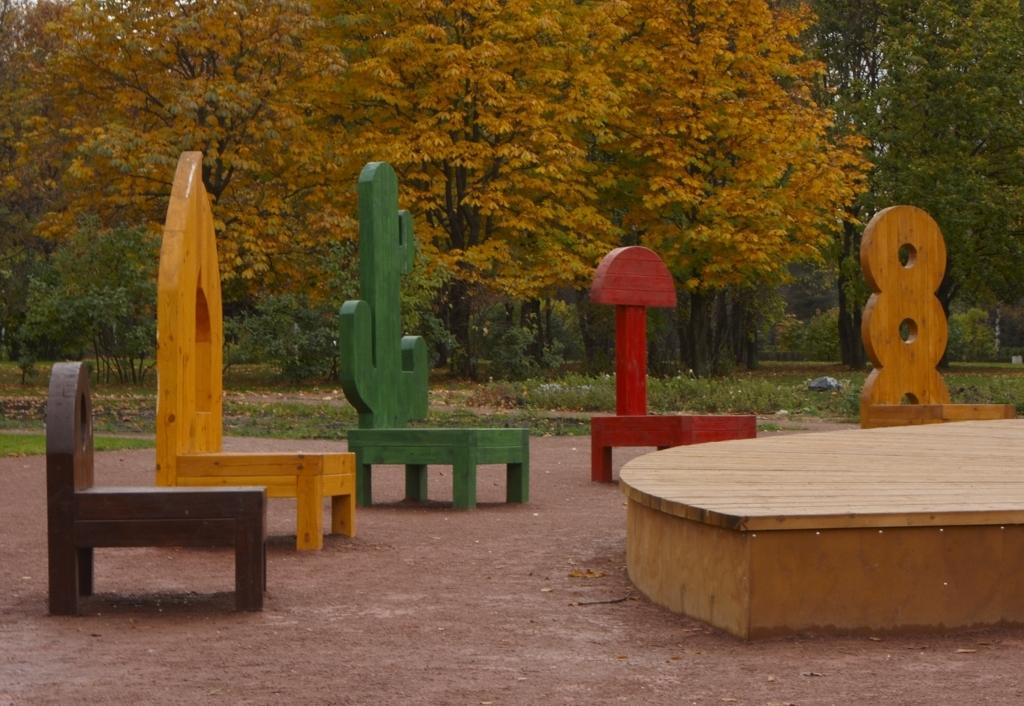What type of chairs are present in the image? There are wooden chairs with different structures in the image. What can be seen in the middle of the image? There are green trees in the middle of the image. What type of silk is being used as bait for the wooden chairs in the image? There is no silk or bait present in the image; it features wooden chairs and green trees. 